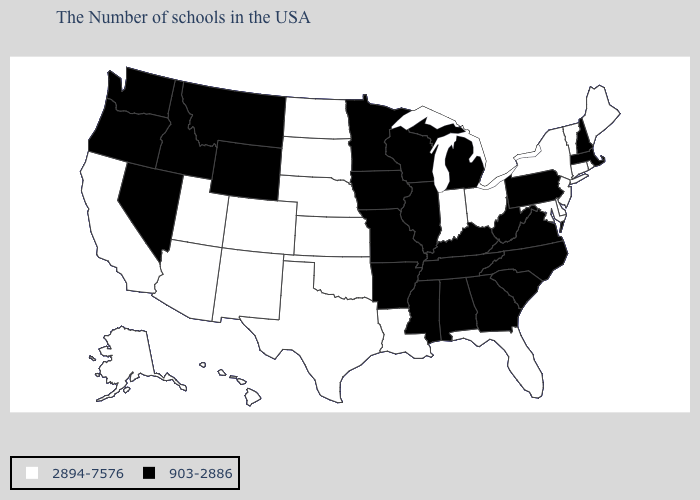Is the legend a continuous bar?
Answer briefly. No. Does the map have missing data?
Concise answer only. No. What is the value of North Carolina?
Quick response, please. 903-2886. What is the value of Arizona?
Quick response, please. 2894-7576. Does Michigan have a lower value than South Dakota?
Short answer required. Yes. What is the highest value in the USA?
Concise answer only. 2894-7576. What is the value of Utah?
Be succinct. 2894-7576. Does Connecticut have the lowest value in the USA?
Be succinct. No. Name the states that have a value in the range 2894-7576?
Concise answer only. Maine, Rhode Island, Vermont, Connecticut, New York, New Jersey, Delaware, Maryland, Ohio, Florida, Indiana, Louisiana, Kansas, Nebraska, Oklahoma, Texas, South Dakota, North Dakota, Colorado, New Mexico, Utah, Arizona, California, Alaska, Hawaii. What is the value of New Mexico?
Quick response, please. 2894-7576. Does Delaware have the lowest value in the South?
Quick response, please. No. What is the value of California?
Answer briefly. 2894-7576. What is the lowest value in states that border Kentucky?
Answer briefly. 903-2886. Name the states that have a value in the range 2894-7576?
Short answer required. Maine, Rhode Island, Vermont, Connecticut, New York, New Jersey, Delaware, Maryland, Ohio, Florida, Indiana, Louisiana, Kansas, Nebraska, Oklahoma, Texas, South Dakota, North Dakota, Colorado, New Mexico, Utah, Arizona, California, Alaska, Hawaii. Name the states that have a value in the range 2894-7576?
Concise answer only. Maine, Rhode Island, Vermont, Connecticut, New York, New Jersey, Delaware, Maryland, Ohio, Florida, Indiana, Louisiana, Kansas, Nebraska, Oklahoma, Texas, South Dakota, North Dakota, Colorado, New Mexico, Utah, Arizona, California, Alaska, Hawaii. 